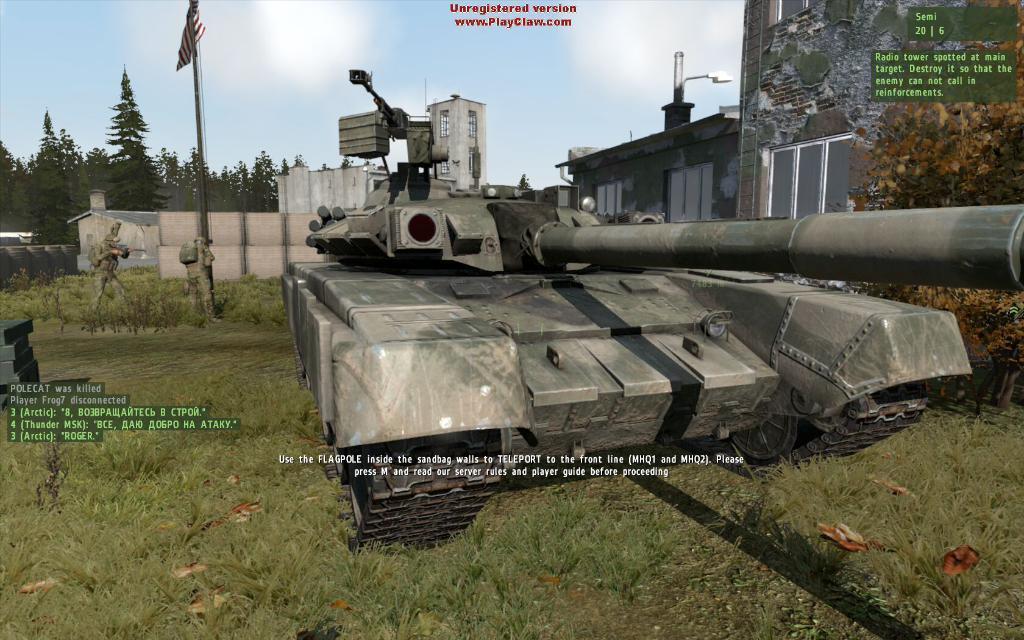Could you give a brief overview of what you see in this image? In the picture I can see the battle tank. I can see the green grass at the bottom of the picture. I can see the building on the right side and I can see the glass windows of the building. I can see two soldiers and a flagpole on the left side. There are clouds in the sky. In the background, I can see the trees. 